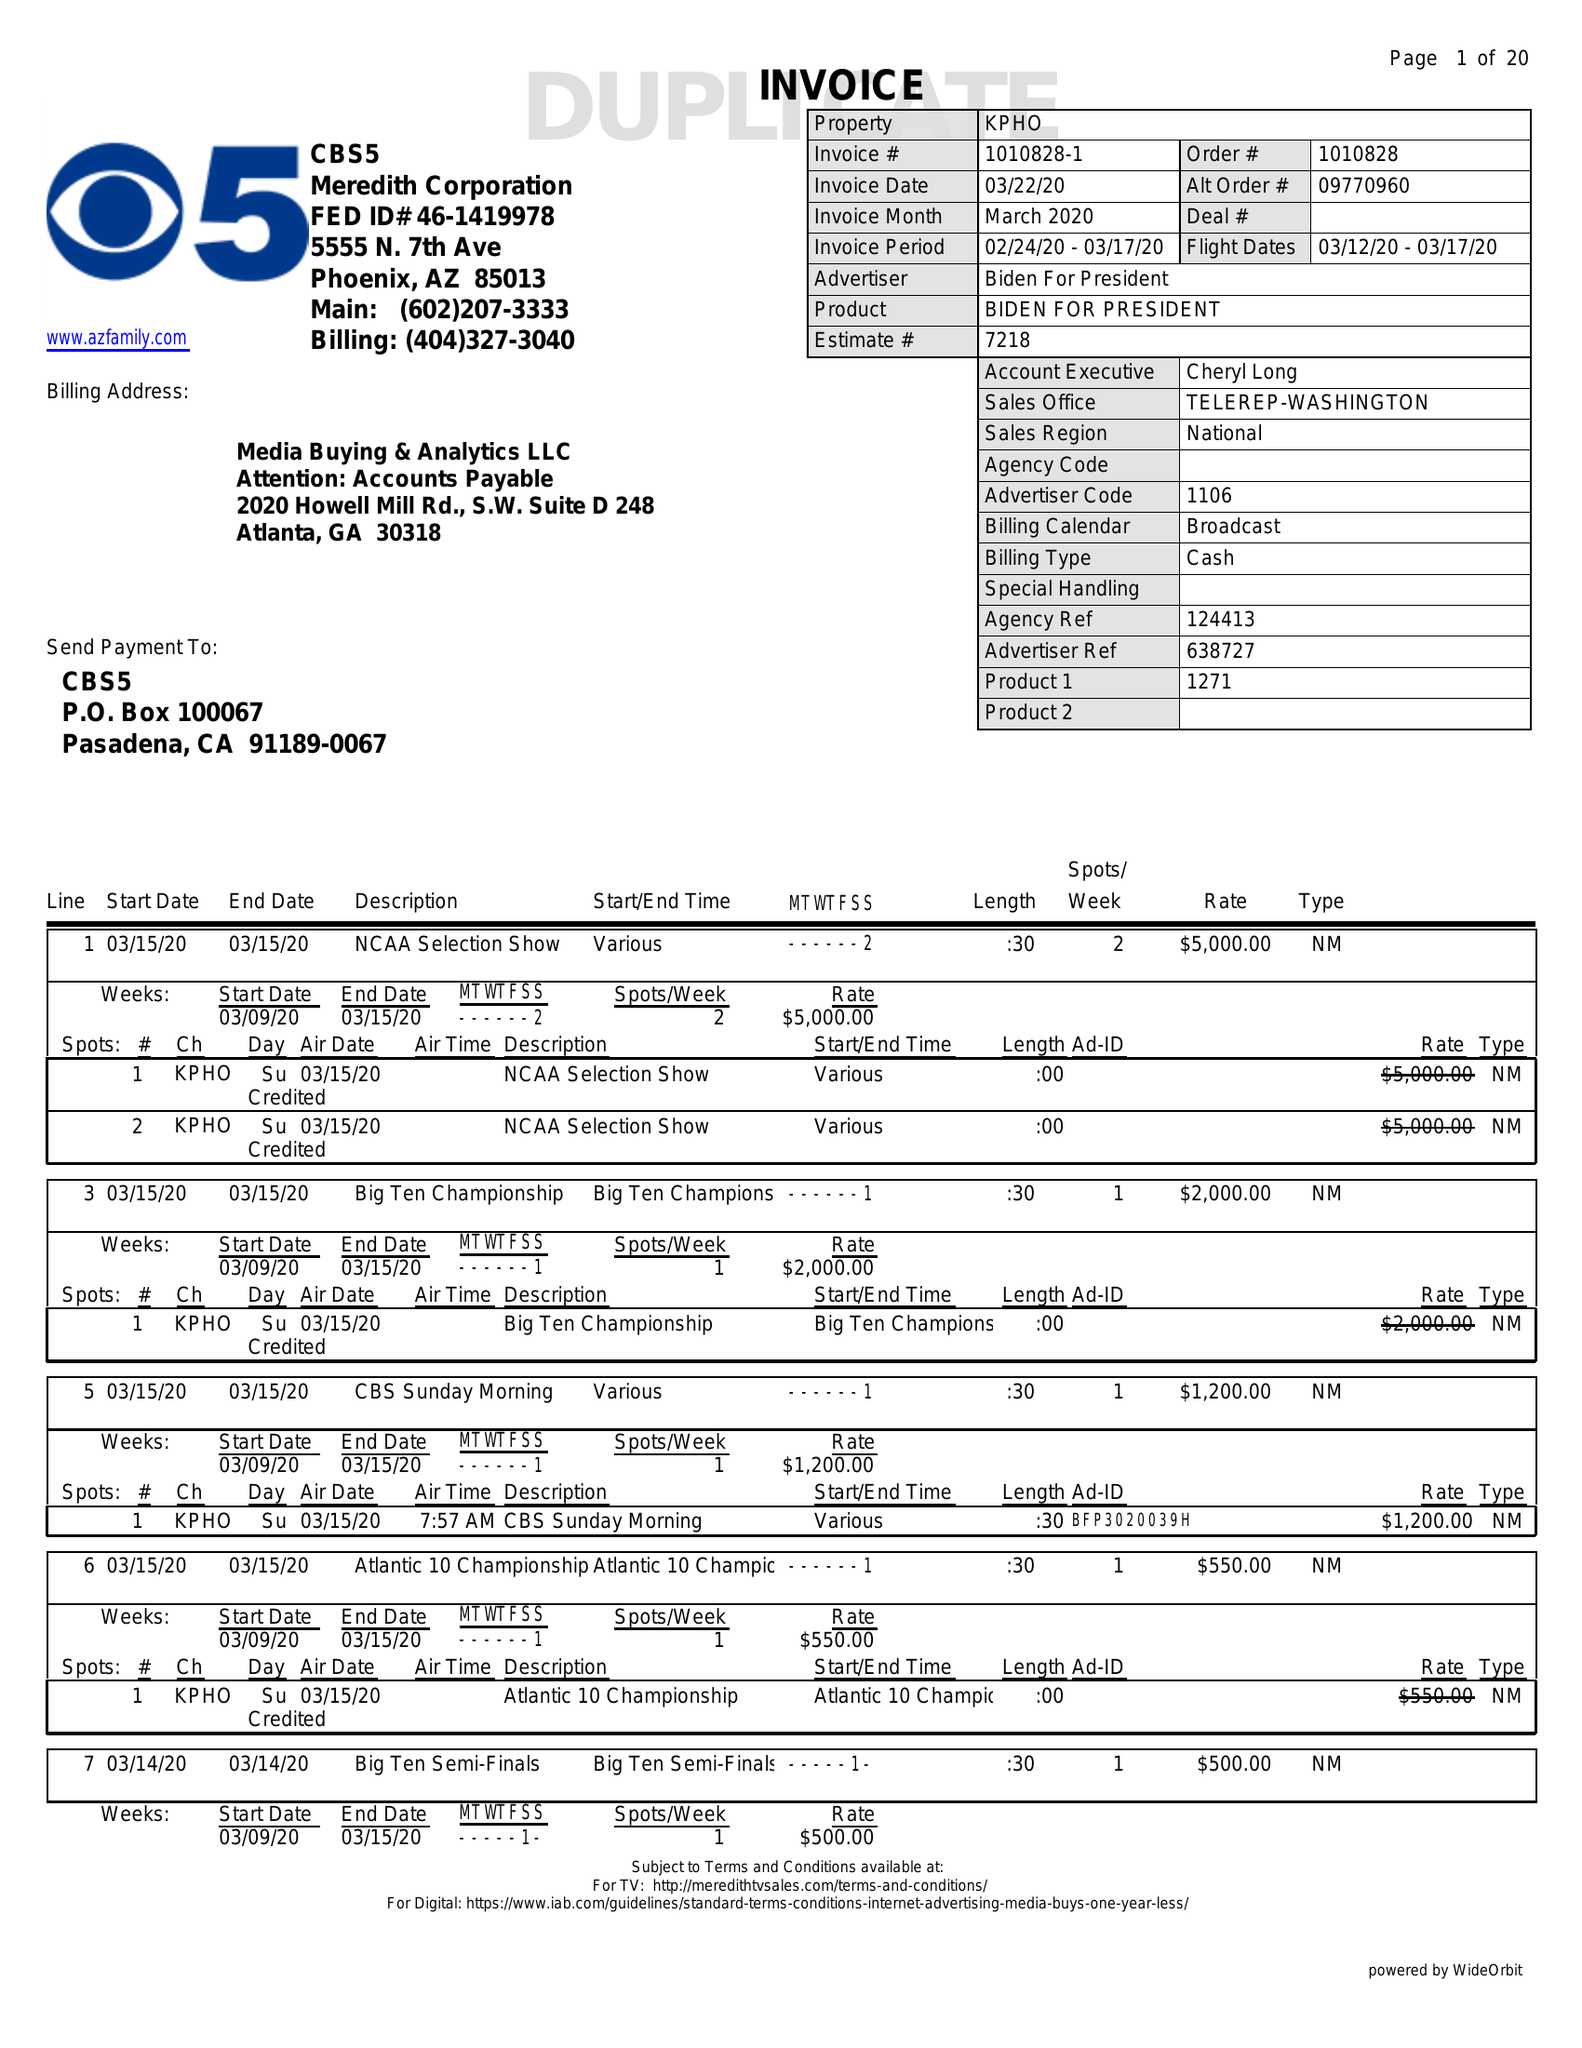What is the value for the flight_to?
Answer the question using a single word or phrase. 03/17/20 